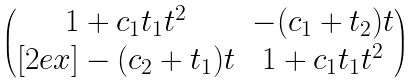Convert formula to latex. <formula><loc_0><loc_0><loc_500><loc_500>\begin{pmatrix} 1 + c _ { 1 } t _ { 1 } t ^ { 2 } & - ( c _ { 1 } + t _ { 2 } ) t \\ [ 2 e x ] - ( c _ { 2 } + t _ { 1 } ) t & 1 + c _ { 1 } t _ { 1 } t ^ { 2 } \end{pmatrix}</formula> 